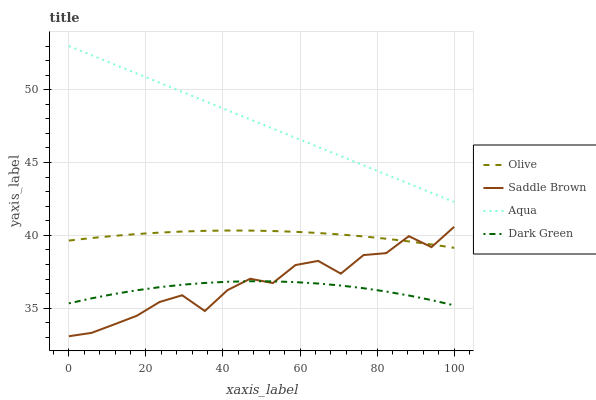Does Dark Green have the minimum area under the curve?
Answer yes or no. Yes. Does Aqua have the maximum area under the curve?
Answer yes or no. Yes. Does Saddle Brown have the minimum area under the curve?
Answer yes or no. No. Does Saddle Brown have the maximum area under the curve?
Answer yes or no. No. Is Aqua the smoothest?
Answer yes or no. Yes. Is Saddle Brown the roughest?
Answer yes or no. Yes. Is Saddle Brown the smoothest?
Answer yes or no. No. Is Aqua the roughest?
Answer yes or no. No. Does Saddle Brown have the lowest value?
Answer yes or no. Yes. Does Aqua have the lowest value?
Answer yes or no. No. Does Aqua have the highest value?
Answer yes or no. Yes. Does Saddle Brown have the highest value?
Answer yes or no. No. Is Dark Green less than Olive?
Answer yes or no. Yes. Is Aqua greater than Olive?
Answer yes or no. Yes. Does Saddle Brown intersect Olive?
Answer yes or no. Yes. Is Saddle Brown less than Olive?
Answer yes or no. No. Is Saddle Brown greater than Olive?
Answer yes or no. No. Does Dark Green intersect Olive?
Answer yes or no. No. 